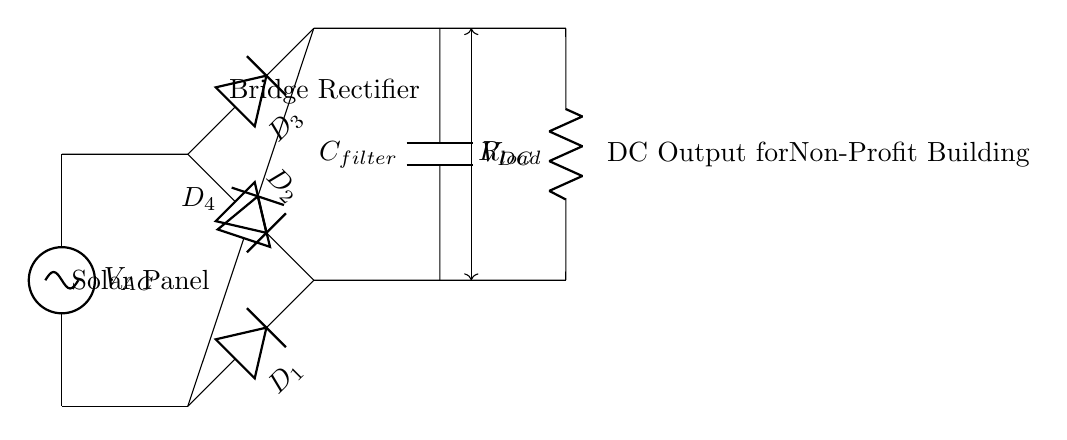What kind of circuit is shown? The circuit is a bridge rectifier, which is specifically designed to convert alternating current (AC) to direct current (DC). This type of circuit uses four diodes arranged in a bridge configuration.
Answer: Bridge rectifier How many diodes are used in this circuit? There are four diodes in the bridge rectifier circuit, labeled D1, D2, D3, and D4. This arrangement is crucial for allowing current to flow in one direction, irrespective of the AC input polarity.
Answer: Four diodes What is the purpose of the capacitor in this circuit? The capacitor, labeled C filter, is used to smooth out the pulsed DC output from the rectifier, reducing voltage fluctuations and providing a more stable DC voltage to the load.
Answer: Smooth DC output What is the meaning of V AC in this circuit? V AC represents the voltage provided by the solar panel, which is an alternating current supply. This is the input voltage that will be converted to direct current by the bridge rectifier.
Answer: Input voltage What does R load represent in the circuit? R load is the load resistor, which represents the electrical load in the non-profit building that will receive the output DC voltage. The value of this resistor determines how much current will flow through the circuit.
Answer: Load resistor What is the output voltage symbol in this circuit? The output voltage from the bridge rectifier is labeled V DC, indicating the direct current voltage that the load will utilize after rectification and filtering.
Answer: V DC How does this bridge rectifier convert AC to DC? The bridge rectifier uses the four diodes to conduct current in a way that allows both halves of the AC waveform to contribute to the output, ensuring that the resulting output is always in the same direction, thus converting AC to DC.
Answer: Conducts current unidirectionally 